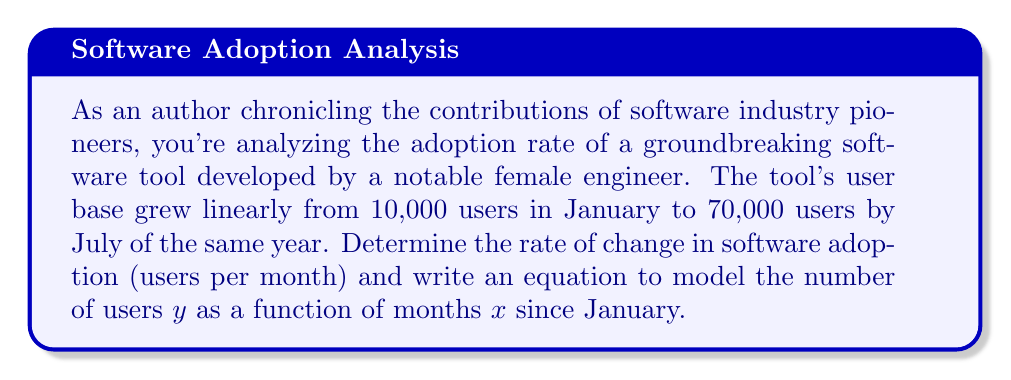What is the answer to this math problem? To solve this problem, we'll use the point-slope form of a linear equation:

$$ y - y_1 = m(x - x_1) $$

Where $m$ is the slope (rate of change), $(x_1, y_1)$ is a known point, $x$ is the independent variable (months), and $y$ is the dependent variable (number of users).

1. Calculate the rate of change (slope):
   * Time period: January to July = 6 months
   * Change in users: 70,000 - 10,000 = 60,000 users
   * Rate of change: $m = \frac{60,000 \text{ users}}{6 \text{ months}} = 10,000 \text{ users/month}$

2. Use the point-slope form with the initial point (0, 10,000):
   $$ y - 10,000 = 10,000(x - 0) $$

3. Simplify to slope-intercept form:
   $$ y = 10,000x + 10,000 $$

This equation models the number of users $y$ as a function of months $x$ since January.
Answer: The rate of change in software adoption is 10,000 users per month. The equation modeling the number of users $y$ as a function of months $x$ since January is:

$$ y = 10,000x + 10,000 $$ 